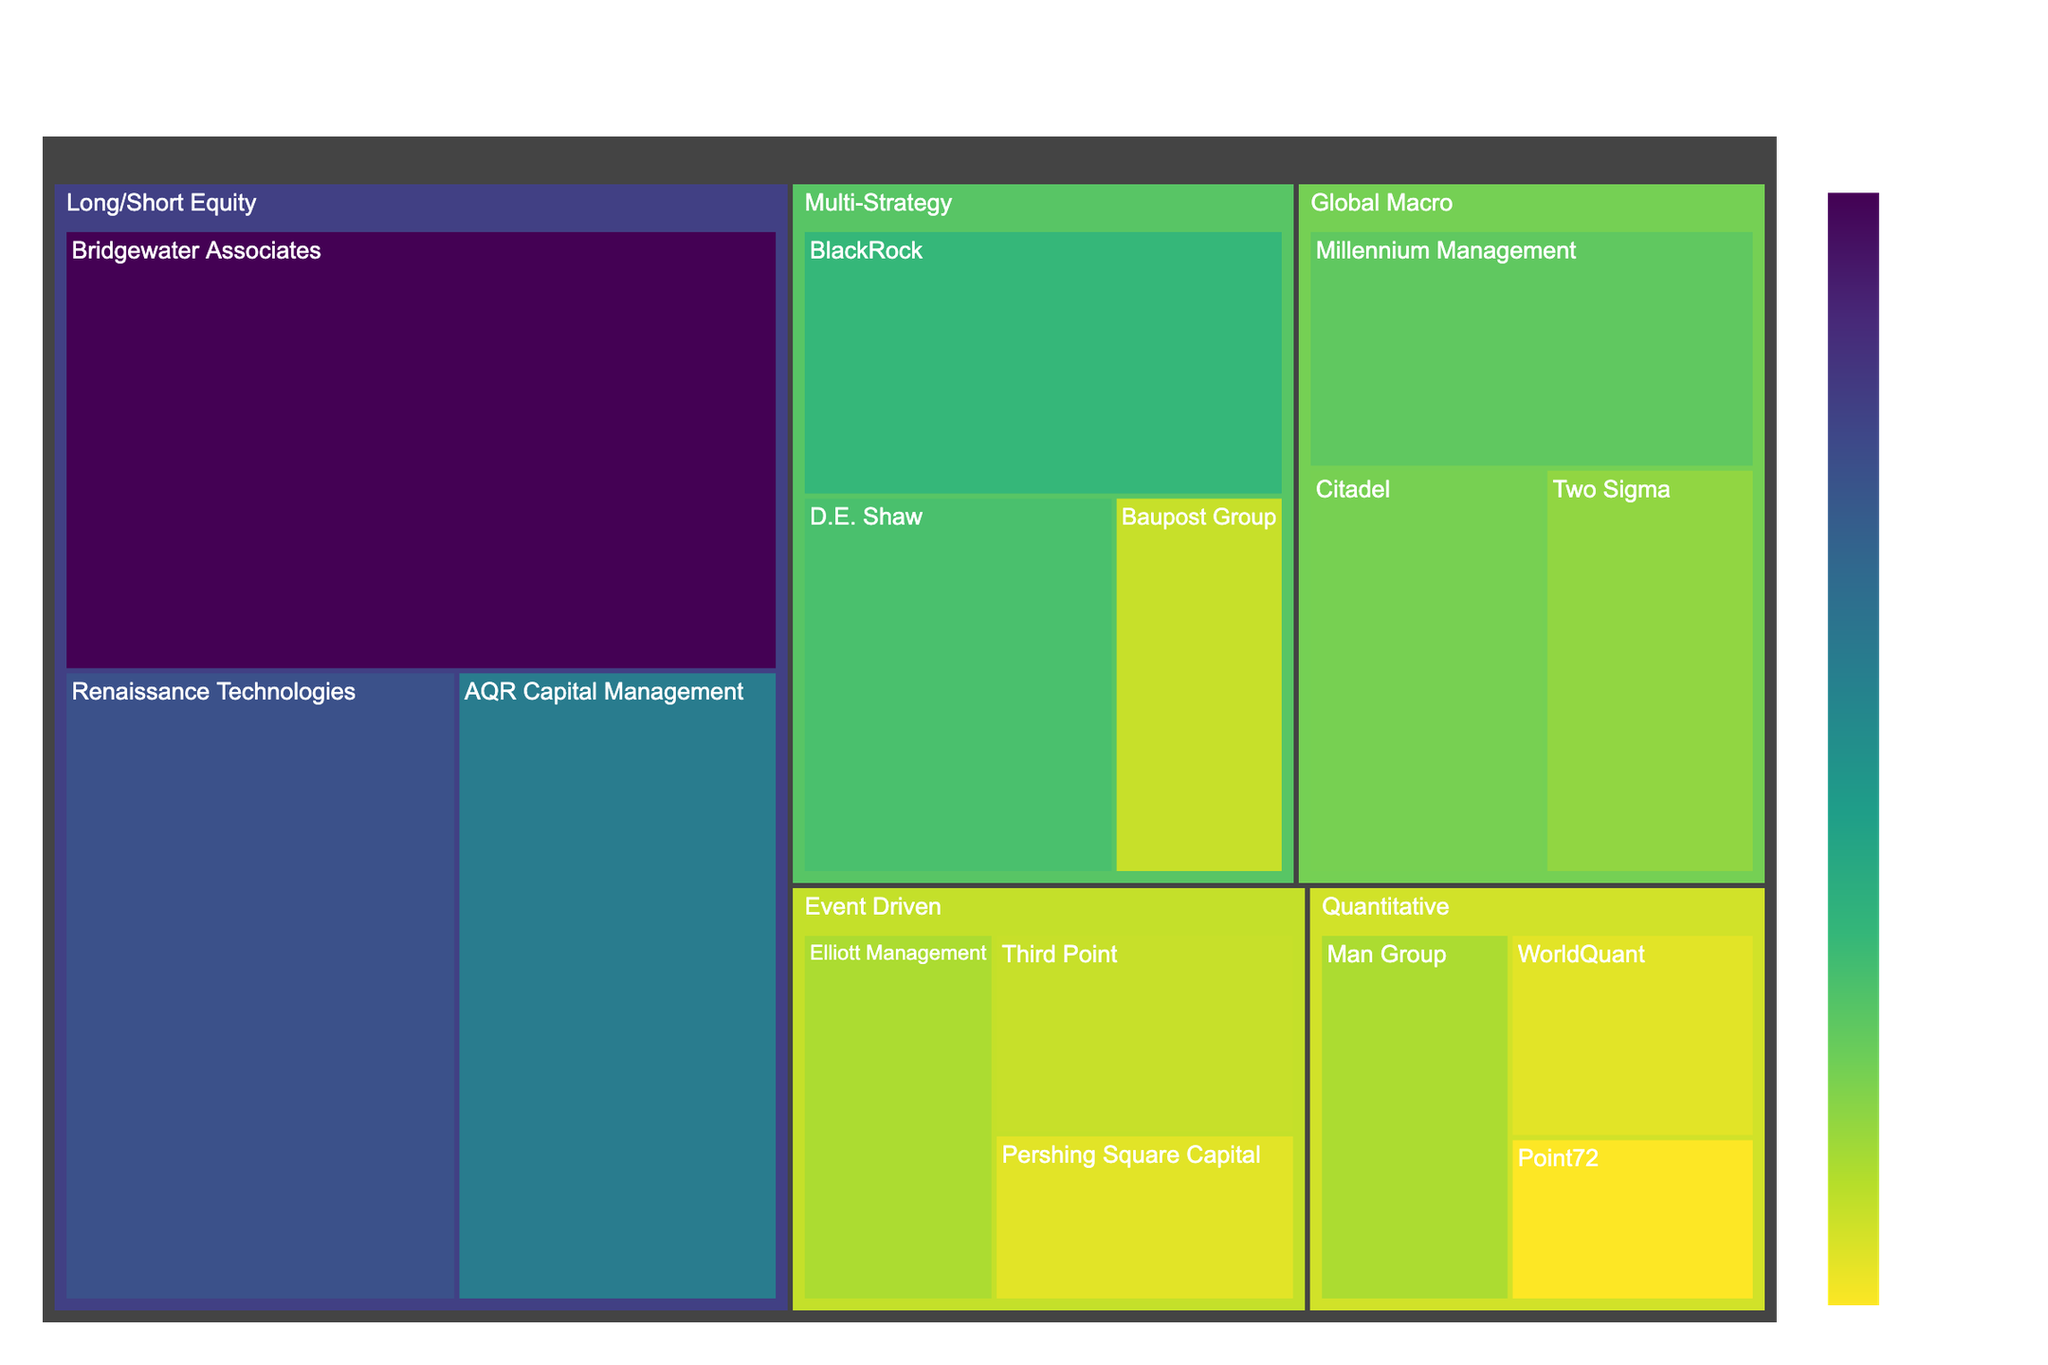What's the top-level title of the figure? The title is usually located at the top of the figure and describes the overall visualized data. Here, it reads "Asset Allocation of Top US Hedge Funds by Investment Strategy."
Answer: Asset Allocation of Top US Hedge Funds by Investment Strategy How many distinct investment strategies are shown in the figure? Each different color block at the highest tree level represents a unique investment strategy. Counting them, we see Long/Short Equity, Global Macro, Event Driven, Multi-Strategy, and Quantitative.
Answer: 5 Which hedge fund has the largest AUM within the Long/Short Equity strategy? The size of the boxes within the Long/Short Equity category corresponds to their AUM. From the figure, Bridgewater Associates has the largest box in this category.
Answer: Bridgewater Associates What is the total AUM for funds categorized under the Global Macro strategy? Adding the AUM for each fund under Global Macro: Millennium Management (50), Citadel (45), and Two Sigma (40), we get 50 + 45 + 40.
Answer: 135 Which investment strategy has the lowest total AUM? Comparing the summed areas for each strategy, we look for the smallest total area. Summing up, we find Quantitative has the lowest total AUM: Man Group (35), WorldQuant (25), and Point72 (20), totaling 80.
Answer: Quantitative How does the AUM of D.E. Shaw under the Multi-Strategy compare to Point72 under the Quantitative strategy? D.E. Shaw's AUM is 55, while Point72's AUM is 20. Thus, D.E. Shaw's AUM is greater.
Answer: D.E. Shaw > Point72 Which strategy has the most hedge funds, and how many are there? By counting the number of smaller boxes within each strategy, we see that Long/Short Equity has the highest number with Bridgewater Associates, Renaissance Technologies, and AQR Capital Management, making 3 funds.
Answer: Long/Short Equity, 3 What is the average AUM of the funds under the Event Driven strategy? Summing the AUM of Event Driven funds: Elliott Management (35), Third Point (30), Pershing Square Capital (25) giving a total of 90. The average is then 90/3.
Answer: 30 In the treemap, which fund under the Multi-Strategy category has the smallest AUM? By visually comparing the sizes of the boxes within the Multi-Strategy category, we see Baupost Group has the smallest box.
Answer: Baupost Group 